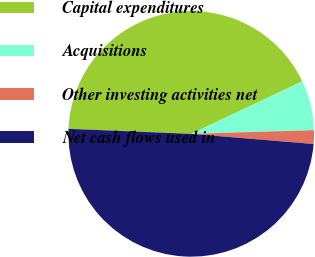Convert chart. <chart><loc_0><loc_0><loc_500><loc_500><pie_chart><fcel>Capital expenditures<fcel>Acquisitions<fcel>Other investing activities net<fcel>Net cash flows used in<nl><fcel>42.31%<fcel>6.55%<fcel>1.8%<fcel>49.33%<nl></chart> 